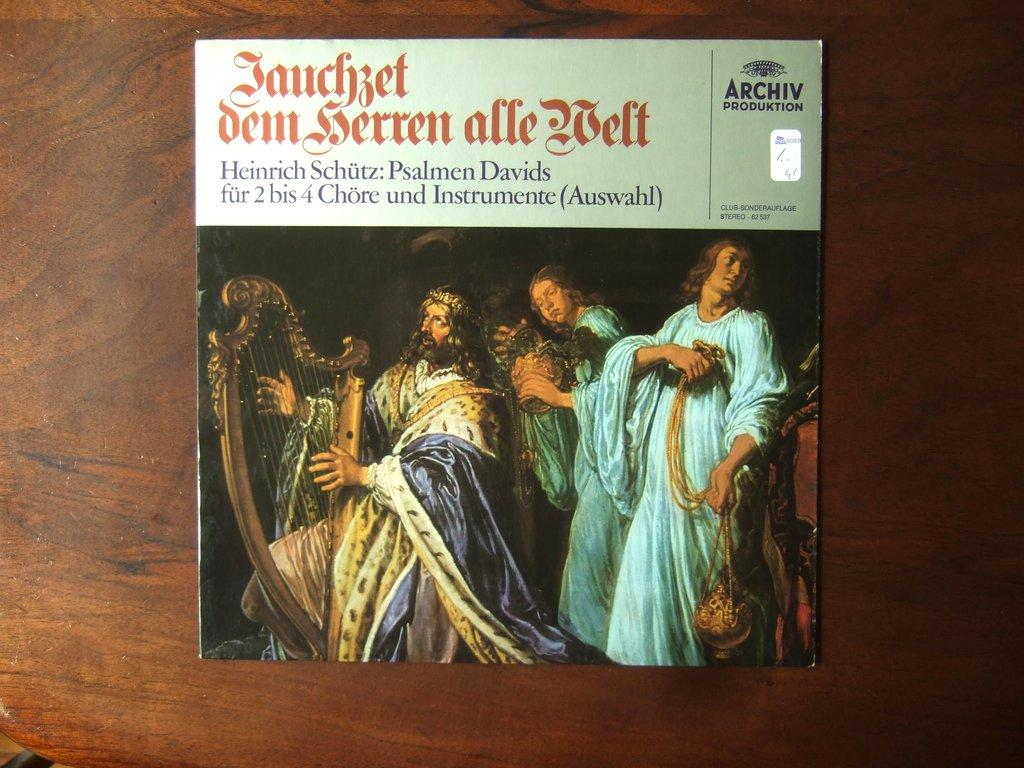<image>
Create a compact narrative representing the image presented. A musical recording by Heinrich Schutz sits on a table. 